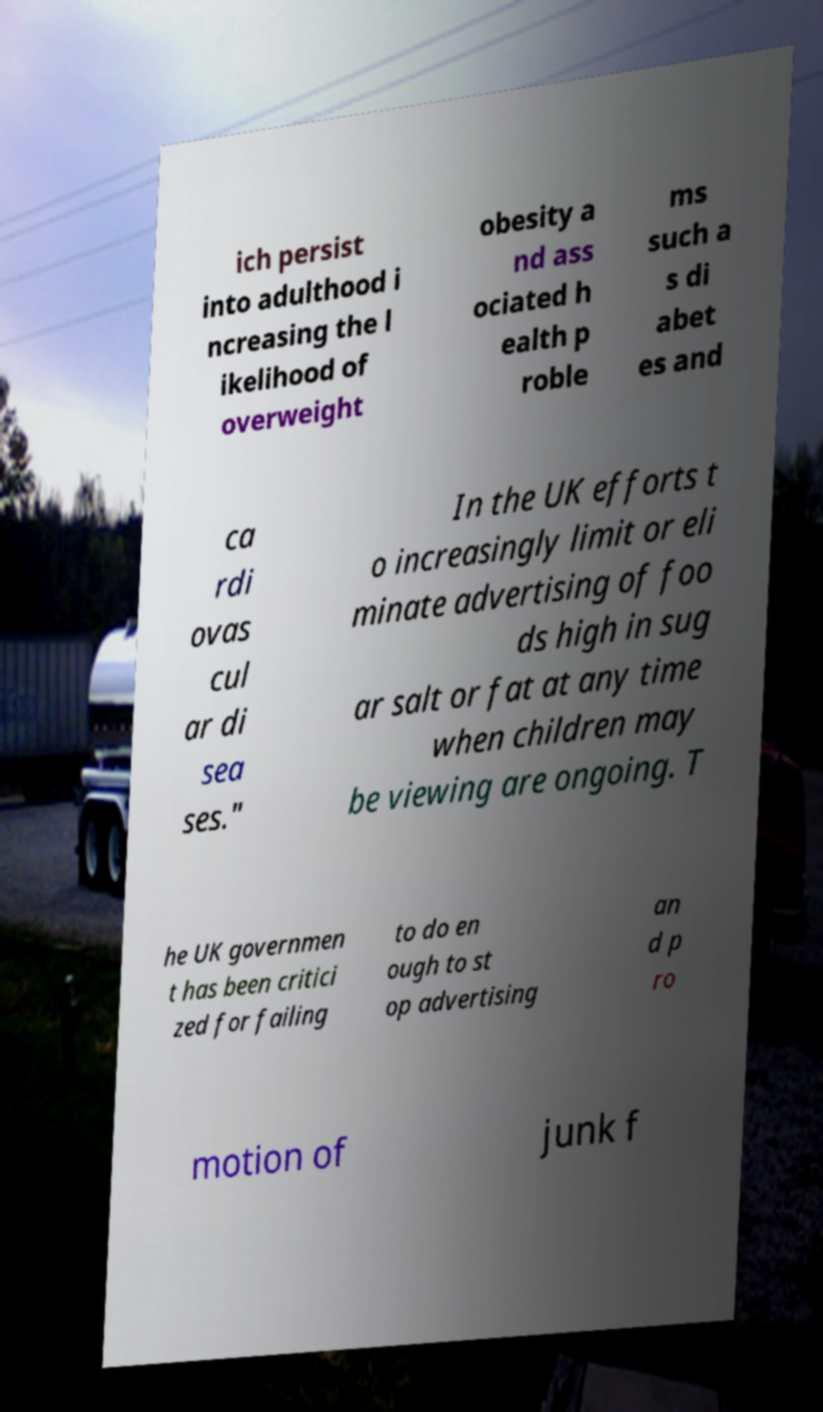Please read and relay the text visible in this image. What does it say? ich persist into adulthood i ncreasing the l ikelihood of overweight obesity a nd ass ociated h ealth p roble ms such a s di abet es and ca rdi ovas cul ar di sea ses." In the UK efforts t o increasingly limit or eli minate advertising of foo ds high in sug ar salt or fat at any time when children may be viewing are ongoing. T he UK governmen t has been critici zed for failing to do en ough to st op advertising an d p ro motion of junk f 